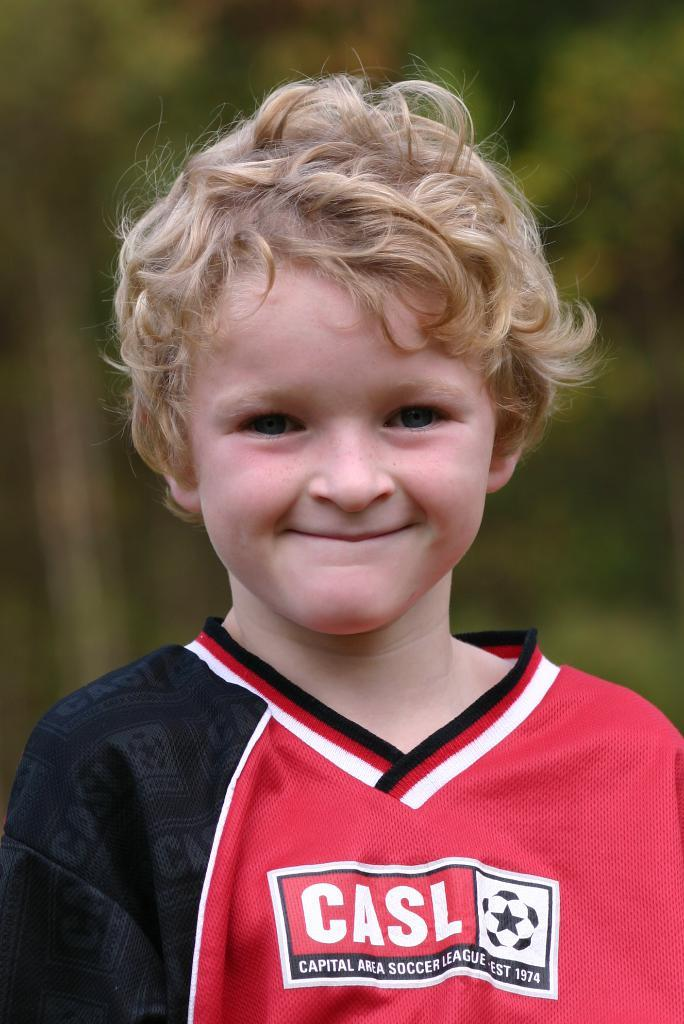<image>
Write a terse but informative summary of the picture. a kid in a Casl jersey for soccer 